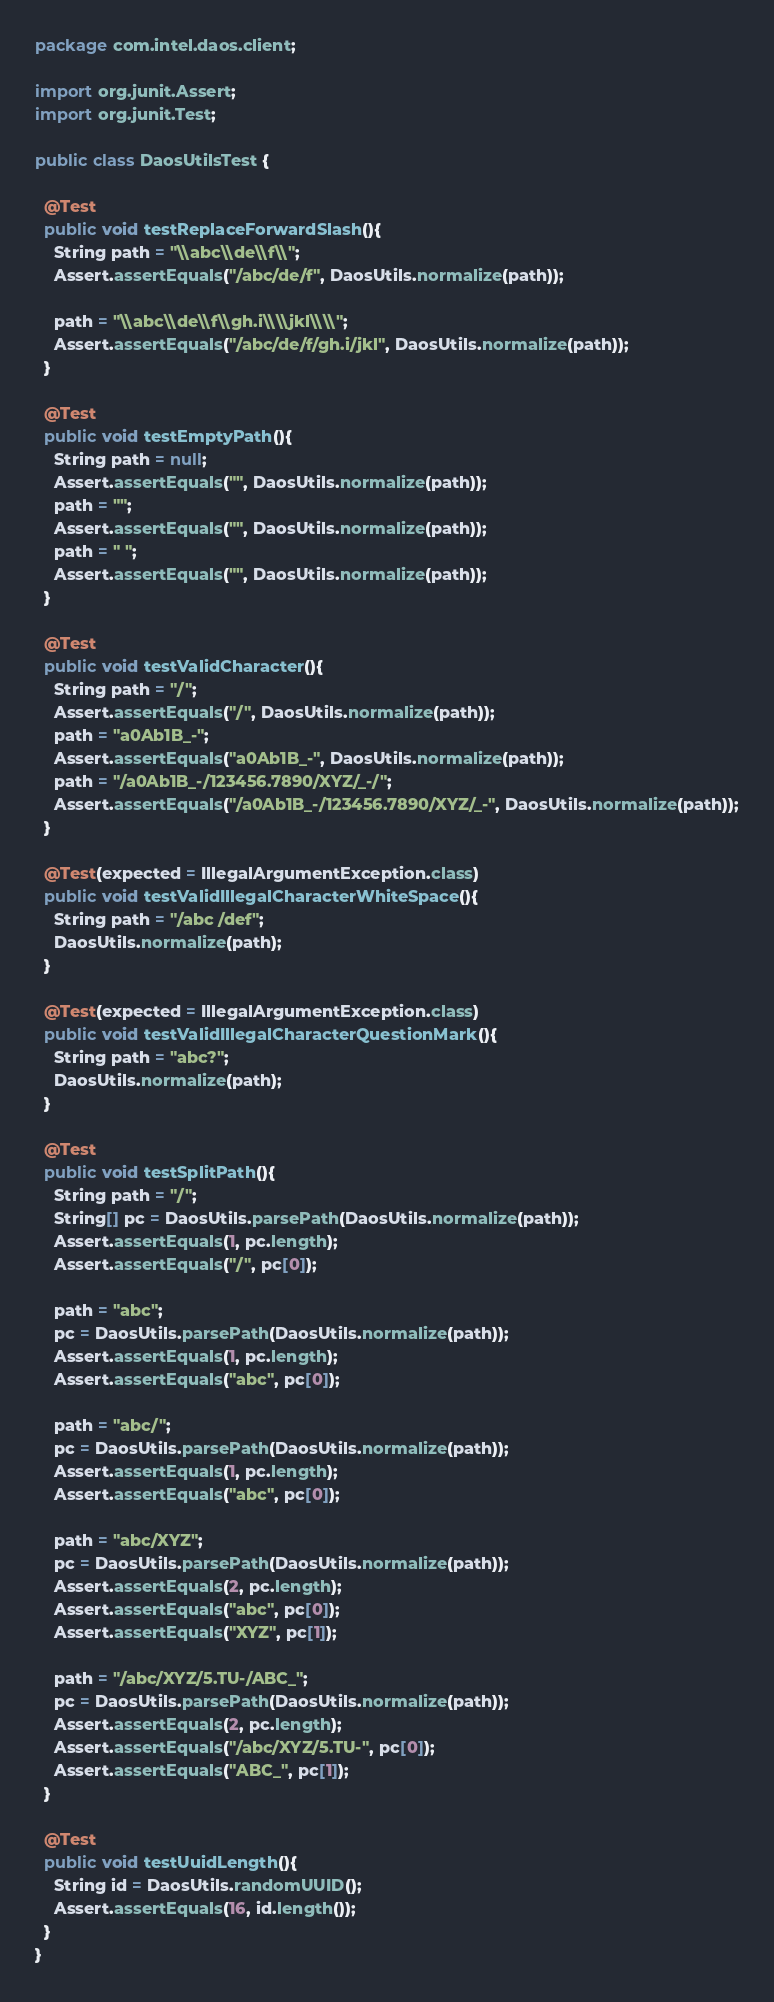<code> <loc_0><loc_0><loc_500><loc_500><_Java_>package com.intel.daos.client;

import org.junit.Assert;
import org.junit.Test;

public class DaosUtilsTest {

  @Test
  public void testReplaceForwardSlash(){
    String path = "\\abc\\de\\f\\";
    Assert.assertEquals("/abc/de/f", DaosUtils.normalize(path));

    path = "\\abc\\de\\f\\gh.i\\\\jkl\\\\";
    Assert.assertEquals("/abc/de/f/gh.i/jkl", DaosUtils.normalize(path));
  }

  @Test
  public void testEmptyPath(){
    String path = null;
    Assert.assertEquals("", DaosUtils.normalize(path));
    path = "";
    Assert.assertEquals("", DaosUtils.normalize(path));
    path = " ";
    Assert.assertEquals("", DaosUtils.normalize(path));
  }

  @Test
  public void testValidCharacter(){
    String path = "/";
    Assert.assertEquals("/", DaosUtils.normalize(path));
    path = "a0Ab1B_-";
    Assert.assertEquals("a0Ab1B_-", DaosUtils.normalize(path));
    path = "/a0Ab1B_-/123456.7890/XYZ/_-/";
    Assert.assertEquals("/a0Ab1B_-/123456.7890/XYZ/_-", DaosUtils.normalize(path));
  }

  @Test(expected = IllegalArgumentException.class)
  public void testValidIllegalCharacterWhiteSpace(){
    String path = "/abc /def";
    DaosUtils.normalize(path);
  }

  @Test(expected = IllegalArgumentException.class)
  public void testValidIllegalCharacterQuestionMark(){
    String path = "abc?";
    DaosUtils.normalize(path);
  }

  @Test
  public void testSplitPath(){
    String path = "/";
    String[] pc = DaosUtils.parsePath(DaosUtils.normalize(path));
    Assert.assertEquals(1, pc.length);
    Assert.assertEquals("/", pc[0]);

    path = "abc";
    pc = DaosUtils.parsePath(DaosUtils.normalize(path));
    Assert.assertEquals(1, pc.length);
    Assert.assertEquals("abc", pc[0]);

    path = "abc/";
    pc = DaosUtils.parsePath(DaosUtils.normalize(path));
    Assert.assertEquals(1, pc.length);
    Assert.assertEquals("abc", pc[0]);

    path = "abc/XYZ";
    pc = DaosUtils.parsePath(DaosUtils.normalize(path));
    Assert.assertEquals(2, pc.length);
    Assert.assertEquals("abc", pc[0]);
    Assert.assertEquals("XYZ", pc[1]);

    path = "/abc/XYZ/5.TU-/ABC_";
    pc = DaosUtils.parsePath(DaosUtils.normalize(path));
    Assert.assertEquals(2, pc.length);
    Assert.assertEquals("/abc/XYZ/5.TU-", pc[0]);
    Assert.assertEquals("ABC_", pc[1]);
  }

  @Test
  public void testUuidLength(){
    String id = DaosUtils.randomUUID();
    Assert.assertEquals(16, id.length());
  }
}







</code> 